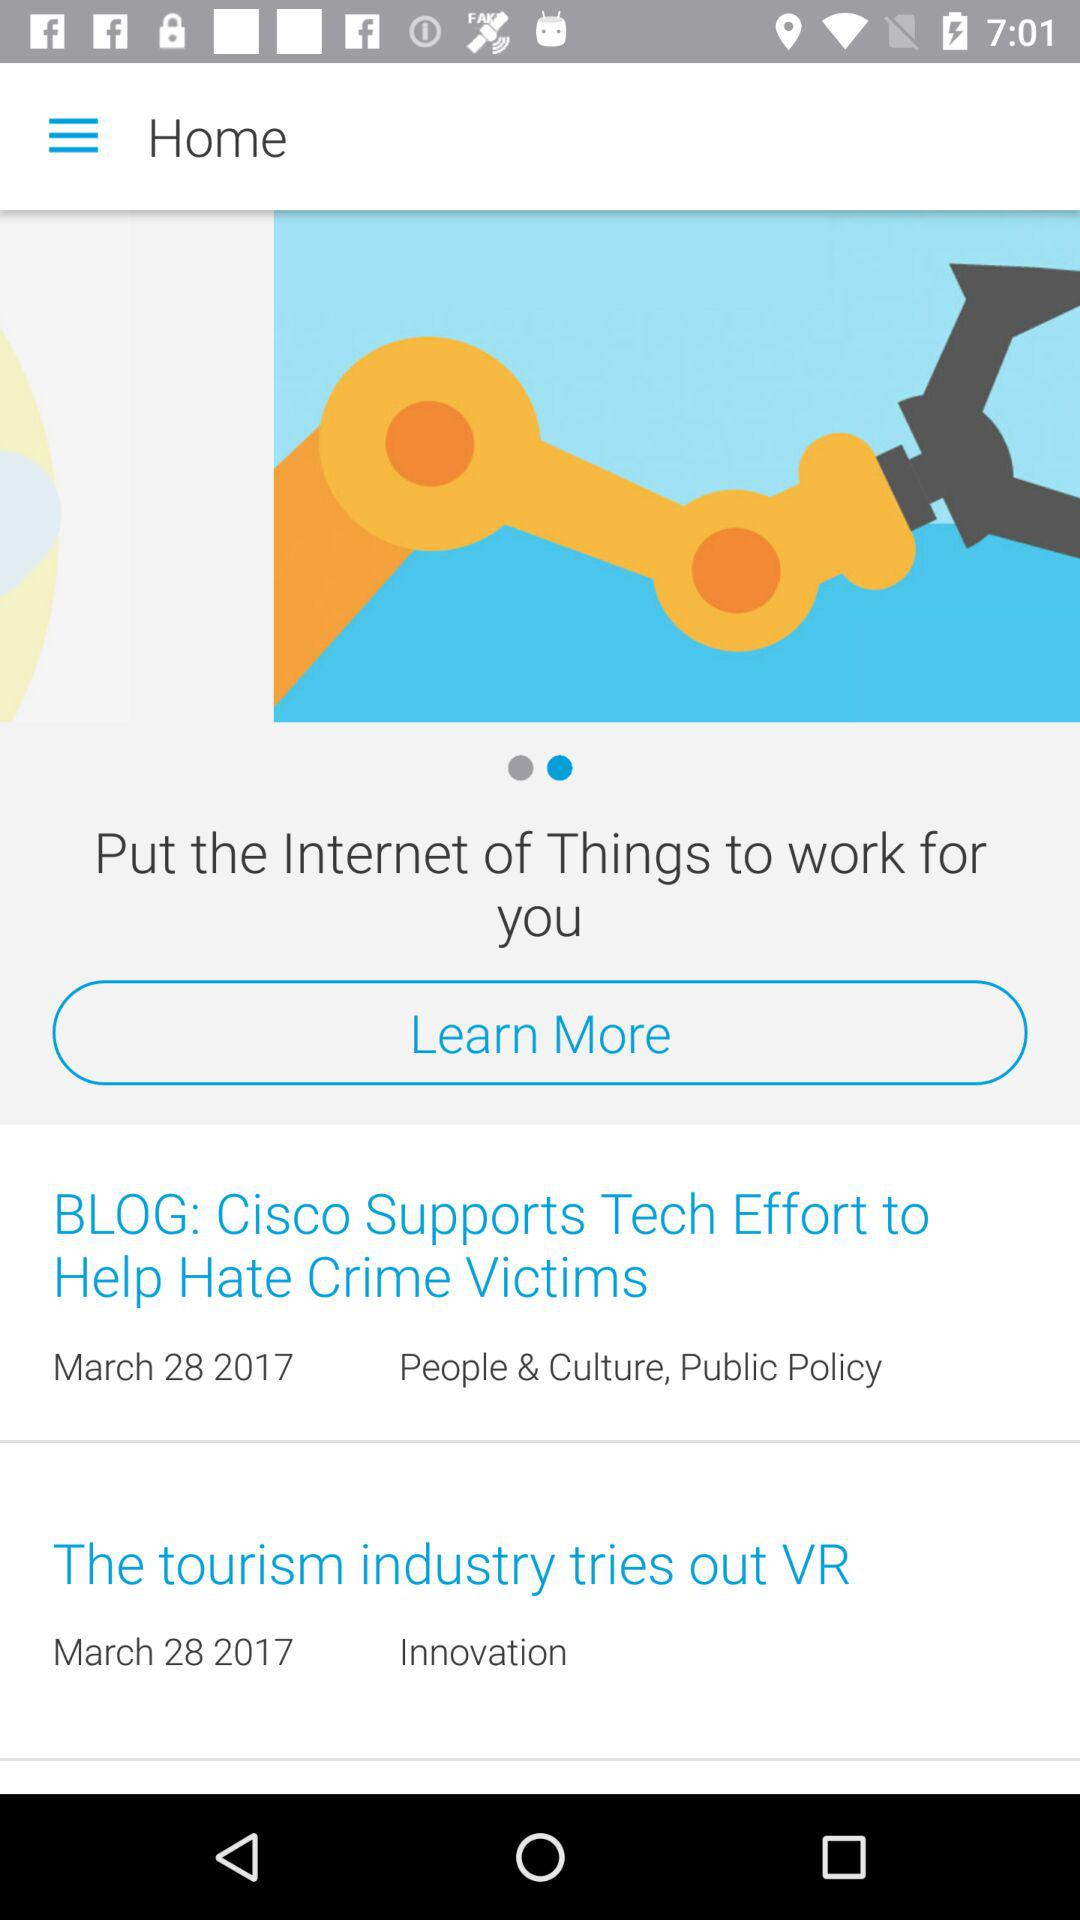Which headline comes under "Innovation"? The headline under "Innovation" is "The tourism industry tries out VR". 